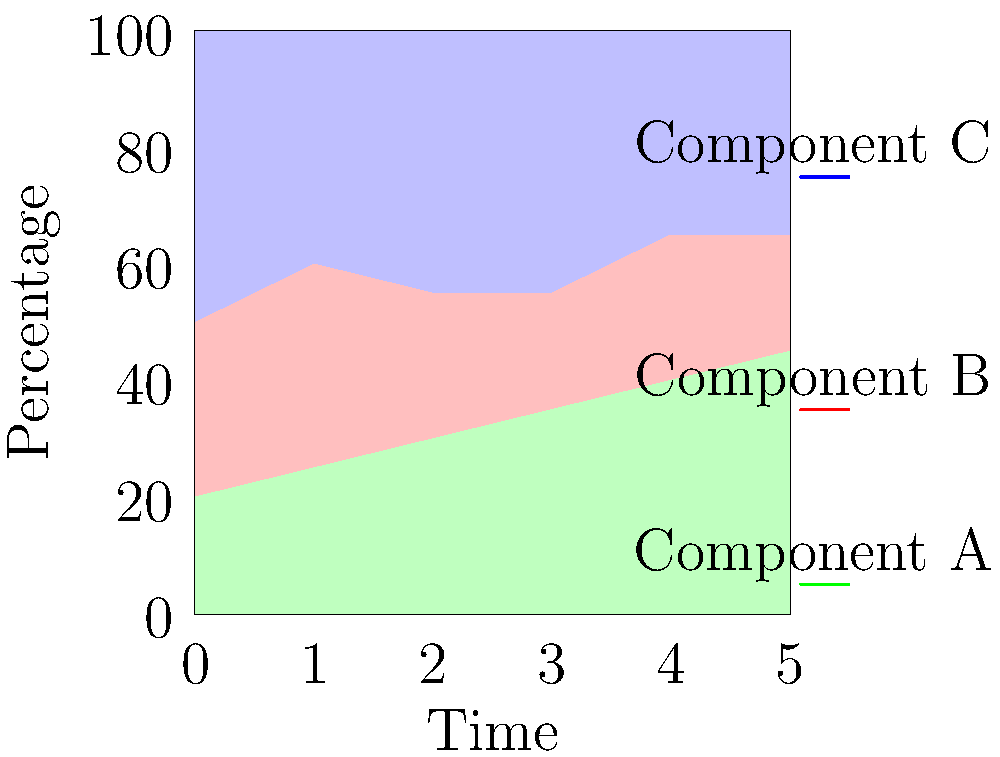As an R programming tutor, you are tasked with creating a stacked area chart to visualize the changing proportions of three components (A, B, and C) over time. The data is provided as three separate vectors representing the percentages of each component at six time points. How would you approach this problem using R's ggplot2 library? To create a stacked area chart in R using ggplot2, follow these steps:

1. First, we need to reshape the data into a long format. We can use the tidyr package for this:

```r
library(tidyr)
library(ggplot2)

# Create the data frame
df <- data.frame(
  Time = 0:5,
  A = c(20,25,30,35,40,45),
  B = c(30,35,25,20,25,20),
  C = c(50,40,45,45,35,35)
)

# Reshape to long format
df_long <- df %>% 
  pivot_longer(cols = c(A, B, C), names_to = "Component", values_to = "Percentage")
```

2. Now, we can create the stacked area chart using ggplot2:

```r
ggplot(df_long, aes(x = Time, y = Percentage, fill = Component)) +
  geom_area() +
  scale_fill_manual(values = c("palegreen", "palered", "paleblue")) +
  theme_minimal() +
  labs(x = "Time", y = "Percentage", title = "Stacked Area Chart of Components over Time")
```

3. Let's break down the ggplot2 code:
   - `ggplot(df_long, aes(x = Time, y = Percentage, fill = Component))`: This sets up the base plot, mapping Time to the x-axis, Percentage to the y-axis, and using Component for fill colors.
   - `geom_area()`: This adds the stacked area geometry.
   - `scale_fill_manual(values = c("palegreen", "palered", "paleblue"))`: This sets custom colors for each component.
   - `theme_minimal()`: This applies a minimal theme for a clean look.
   - `labs()`: This adds labels to the axes and a title to the plot.

4. The resulting plot will show the changing proportions of components A, B, and C over time, with each component represented by a different color in the stacked areas.
Answer: ggplot(df_long, aes(x = Time, y = Percentage, fill = Component)) + geom_area() + scale_fill_manual(values = c("palegreen", "palered", "paleblue")) + theme_minimal() + labs(x = "Time", y = "Percentage", title = "Stacked Area Chart of Components over Time") 